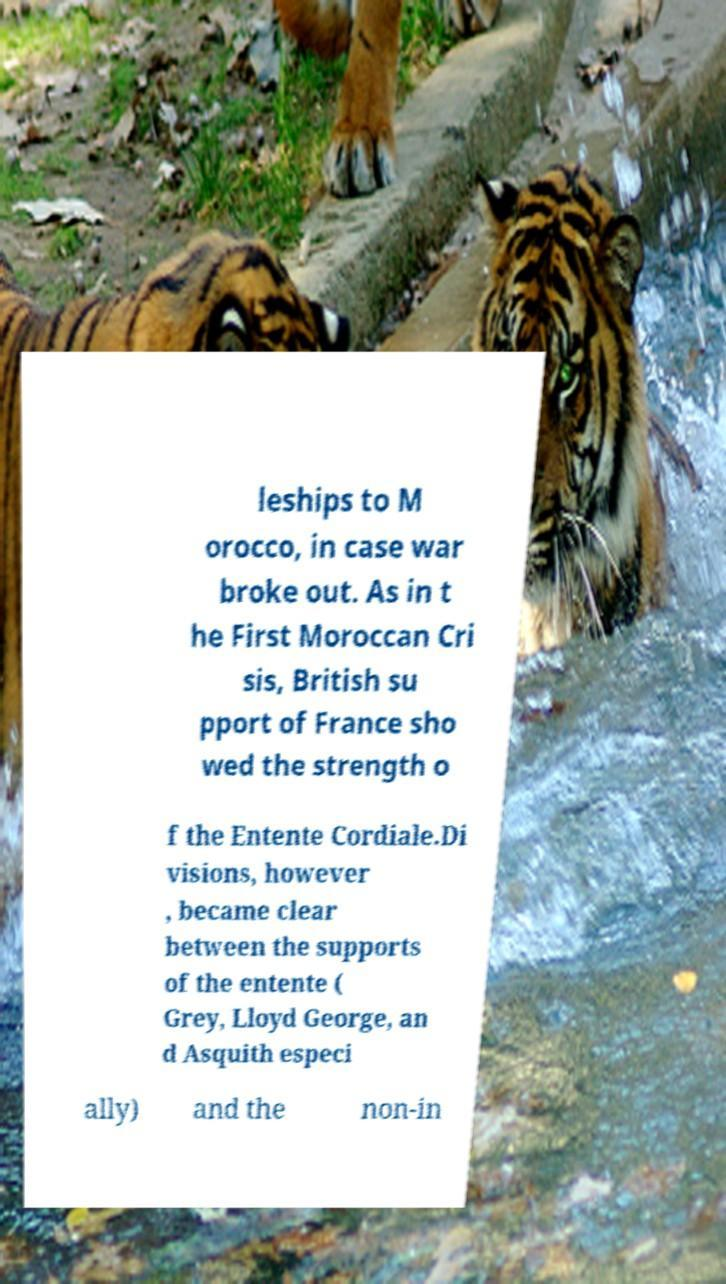Could you assist in decoding the text presented in this image and type it out clearly? leships to M orocco, in case war broke out. As in t he First Moroccan Cri sis, British su pport of France sho wed the strength o f the Entente Cordiale.Di visions, however , became clear between the supports of the entente ( Grey, Lloyd George, an d Asquith especi ally) and the non-in 